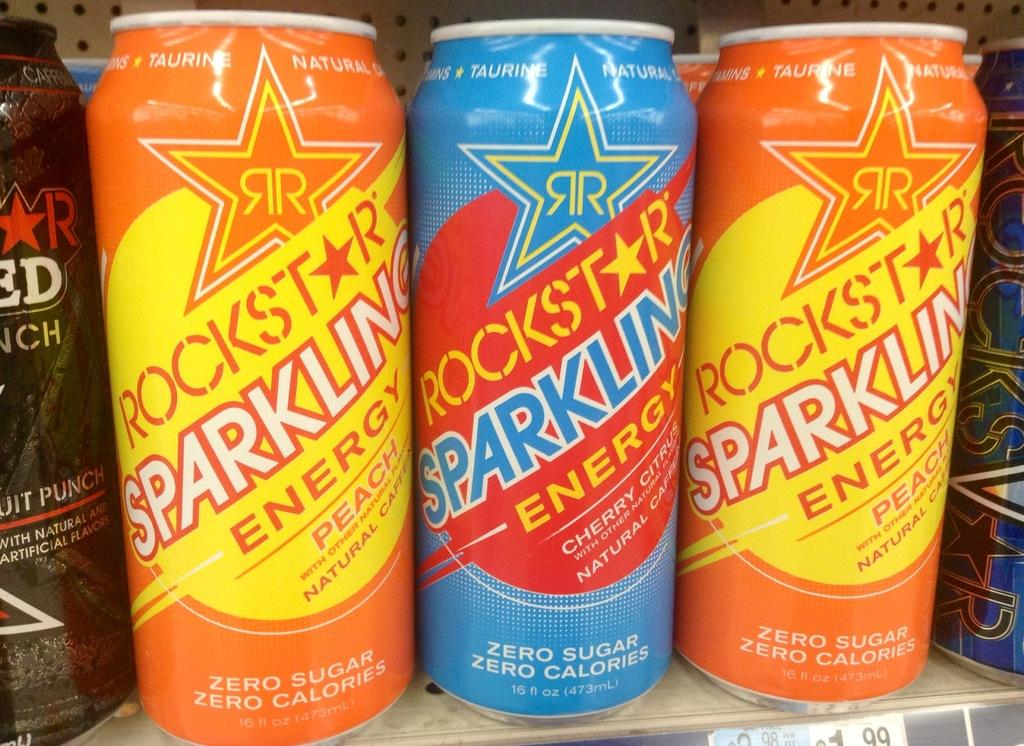<image>
Describe the image concisely. A row of energy drinks that say Rockstar Sparkling Energy. 